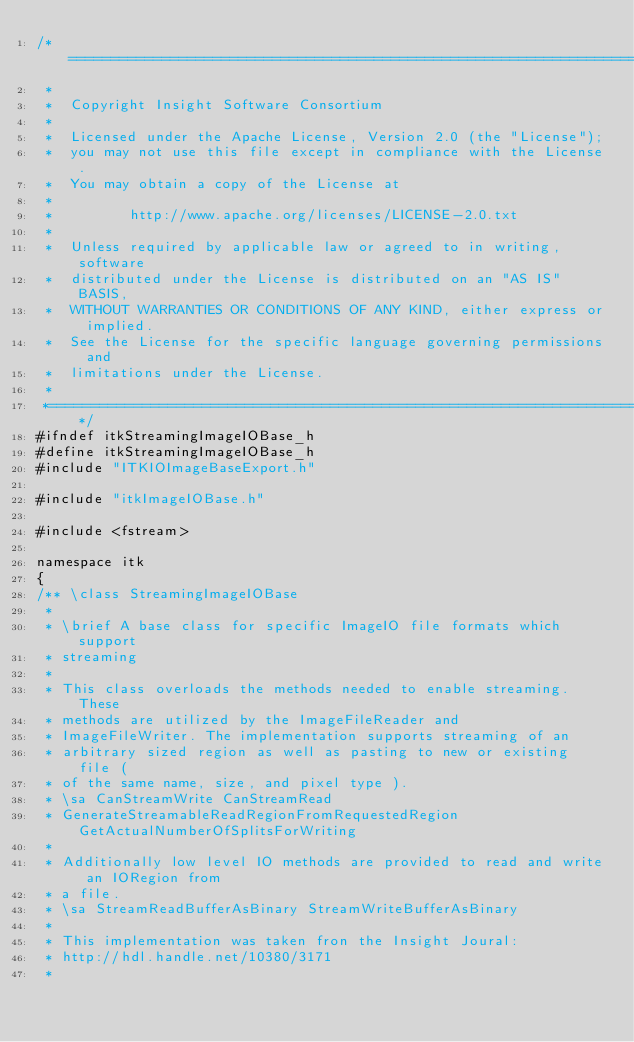Convert code to text. <code><loc_0><loc_0><loc_500><loc_500><_C_>/*=========================================================================
 *
 *  Copyright Insight Software Consortium
 *
 *  Licensed under the Apache License, Version 2.0 (the "License");
 *  you may not use this file except in compliance with the License.
 *  You may obtain a copy of the License at
 *
 *         http://www.apache.org/licenses/LICENSE-2.0.txt
 *
 *  Unless required by applicable law or agreed to in writing, software
 *  distributed under the License is distributed on an "AS IS" BASIS,
 *  WITHOUT WARRANTIES OR CONDITIONS OF ANY KIND, either express or implied.
 *  See the License for the specific language governing permissions and
 *  limitations under the License.
 *
 *=========================================================================*/
#ifndef itkStreamingImageIOBase_h
#define itkStreamingImageIOBase_h
#include "ITKIOImageBaseExport.h"

#include "itkImageIOBase.h"

#include <fstream>

namespace itk
{
/** \class StreamingImageIOBase
 *
 * \brief A base class for specific ImageIO file formats which support
 * streaming
 *
 * This class overloads the methods needed to enable streaming. These
 * methods are utilized by the ImageFileReader and
 * ImageFileWriter. The implementation supports streaming of an
 * arbitrary sized region as well as pasting to new or existing file (
 * of the same name, size, and pixel type ).
 * \sa CanStreamWrite CanStreamRead
 * GenerateStreamableReadRegionFromRequestedRegion GetActualNumberOfSplitsForWriting
 *
 * Additionally low level IO methods are provided to read and write an IORegion from
 * a file.
 * \sa StreamReadBufferAsBinary StreamWriteBufferAsBinary
 *
 * This implementation was taken fron the Insight Joural:
 * http://hdl.handle.net/10380/3171
 *</code> 